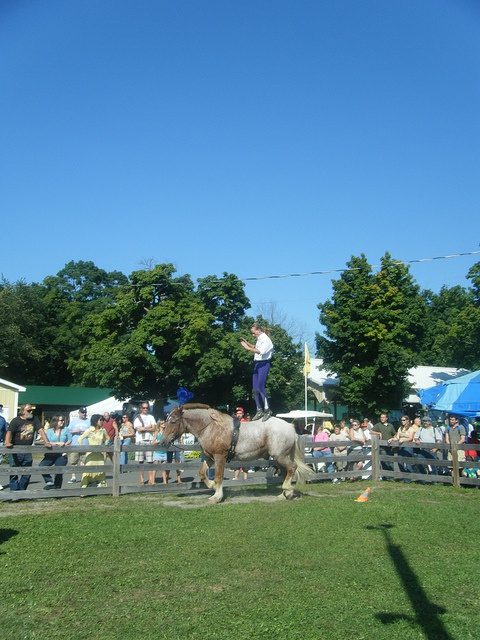Describe the objects in this image and their specific colors. I can see horse in blue, gray, darkgray, and lightgray tones, people in blue, gray, lightgray, darkgray, and black tones, people in blue, black, gray, and darkgray tones, umbrella in blue and lightblue tones, and people in blue, white, gray, and navy tones in this image. 